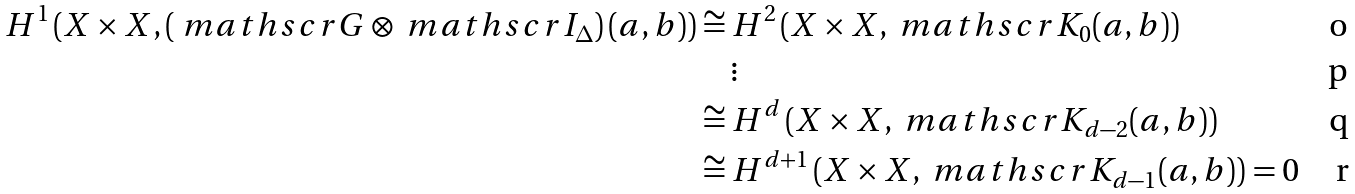<formula> <loc_0><loc_0><loc_500><loc_500>H ^ { 1 } \left ( X \times X , \left ( \ m a t h s c r { G } \otimes \ m a t h s c r { I } _ { \Delta } \right ) ( a , b ) \right ) & \cong H ^ { 2 } \left ( X \times X , \ m a t h s c r { K } _ { 0 } ( a , b ) \right ) \\ & \quad \vdots \\ & \cong H ^ { d } \left ( X \times X , \ m a t h s c r { K } _ { d - 2 } ( a , b ) \right ) \\ & \cong H ^ { d + 1 } \left ( X \times X , \ m a t h s c r { K } _ { d - 1 } ( a , b ) \right ) = 0</formula> 